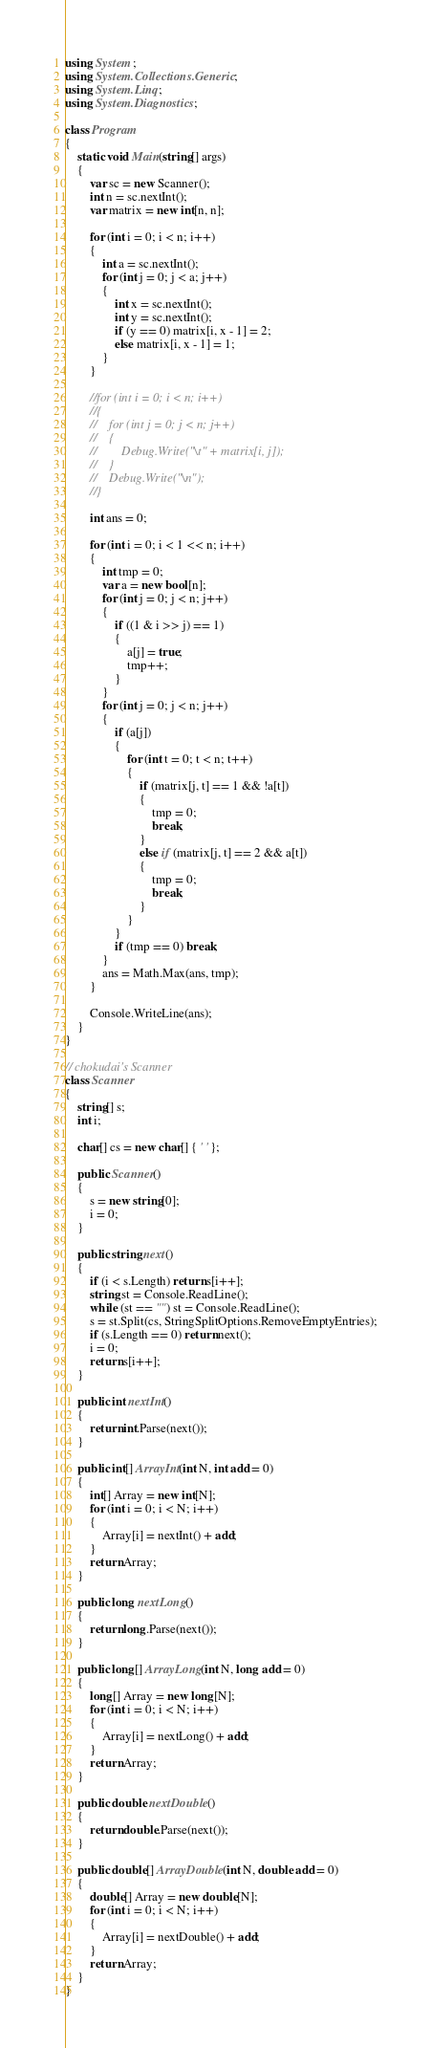<code> <loc_0><loc_0><loc_500><loc_500><_C#_>using System;
using System.Collections.Generic;
using System.Linq;
using System.Diagnostics;

class Program
{
    static void Main(string[] args)
    {
        var sc = new Scanner();
        int n = sc.nextInt();
        var matrix = new int[n, n];

        for (int i = 0; i < n; i++)
        {
            int a = sc.nextInt();
            for (int j = 0; j < a; j++)
            {
                int x = sc.nextInt();
                int y = sc.nextInt();
                if (y == 0) matrix[i, x - 1] = 2;
                else matrix[i, x - 1] = 1;
            }
        }

        //for (int i = 0; i < n; i++)
        //{
        //    for (int j = 0; j < n; j++)
        //    {
        //        Debug.Write("\t" + matrix[i, j]);
        //    }
        //    Debug.Write("\n");
        //}

        int ans = 0;

        for (int i = 0; i < 1 << n; i++)
        {
            int tmp = 0;
            var a = new bool[n];
            for (int j = 0; j < n; j++)
            {
                if ((1 & i >> j) == 1)
                {
                    a[j] = true;
                    tmp++;
                }
            }
            for (int j = 0; j < n; j++)
            {
                if (a[j])
                {
                    for (int t = 0; t < n; t++)
                    {
                        if (matrix[j, t] == 1 && !a[t])
                        {
                            tmp = 0;
                            break;
                        }
                        else if (matrix[j, t] == 2 && a[t])
                        {
                            tmp = 0;
                            break;
                        }
                    }
                }
                if (tmp == 0) break;
            }
            ans = Math.Max(ans, tmp);
        }

        Console.WriteLine(ans);
    }
}

// chokudai's Scanner
class Scanner
{
    string[] s;
    int i;

    char[] cs = new char[] { ' ' };

    public Scanner()
    {
        s = new string[0];
        i = 0;
    }

    public string next()
    {
        if (i < s.Length) return s[i++];
        string st = Console.ReadLine();
        while (st == "") st = Console.ReadLine();
        s = st.Split(cs, StringSplitOptions.RemoveEmptyEntries);
        if (s.Length == 0) return next();
        i = 0;
        return s[i++];
    }

    public int nextInt()
    {
        return int.Parse(next());
    }

    public int[] ArrayInt(int N, int add = 0)
    {
        int[] Array = new int[N];
        for (int i = 0; i < N; i++)
        {
            Array[i] = nextInt() + add;
        }
        return Array;
    }

    public long nextLong()
    {
        return long.Parse(next());
    }

    public long[] ArrayLong(int N, long add = 0)
    {
        long[] Array = new long[N];
        for (int i = 0; i < N; i++)
        {
            Array[i] = nextLong() + add;
        }
        return Array;
    }

    public double nextDouble()
    {
        return double.Parse(next());
    }

    public double[] ArrayDouble(int N, double add = 0)
    {
        double[] Array = new double[N];
        for (int i = 0; i < N; i++)
        {
            Array[i] = nextDouble() + add;
        }
        return Array;
    }
}
</code> 